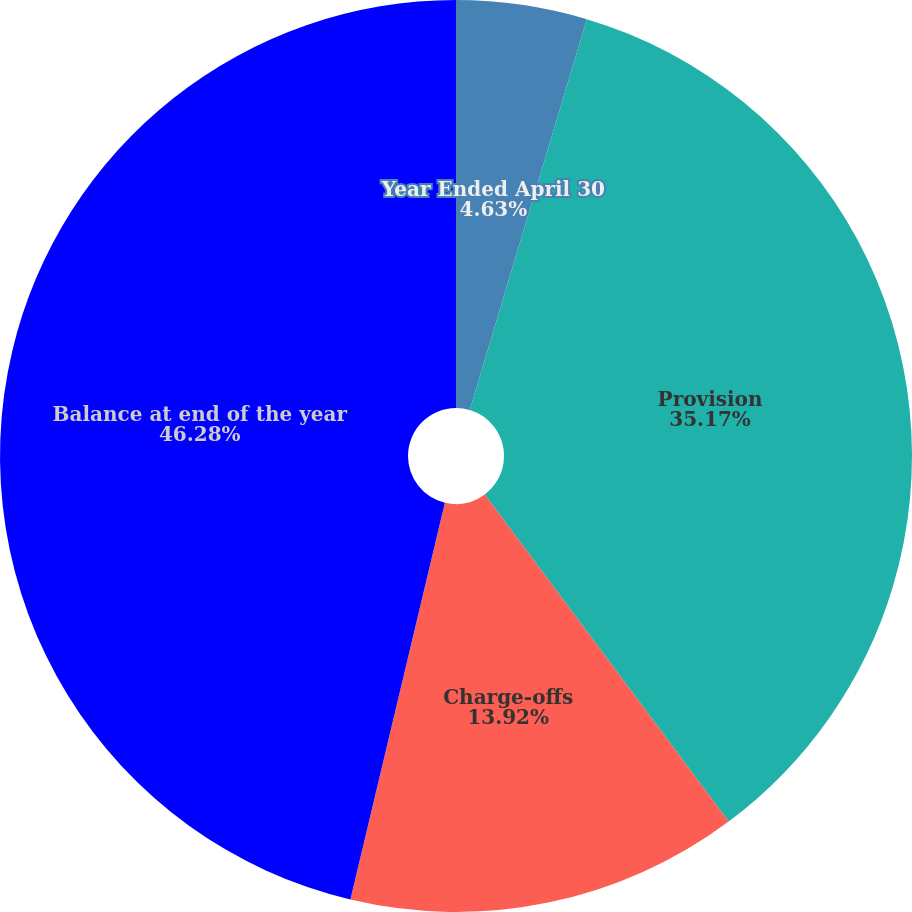<chart> <loc_0><loc_0><loc_500><loc_500><pie_chart><fcel>Year Ended April 30<fcel>Provision<fcel>Charge-offs<fcel>Balance at end of the year<fcel>Ratio of net charge-offs to<nl><fcel>4.63%<fcel>35.17%<fcel>13.92%<fcel>46.28%<fcel>0.0%<nl></chart> 